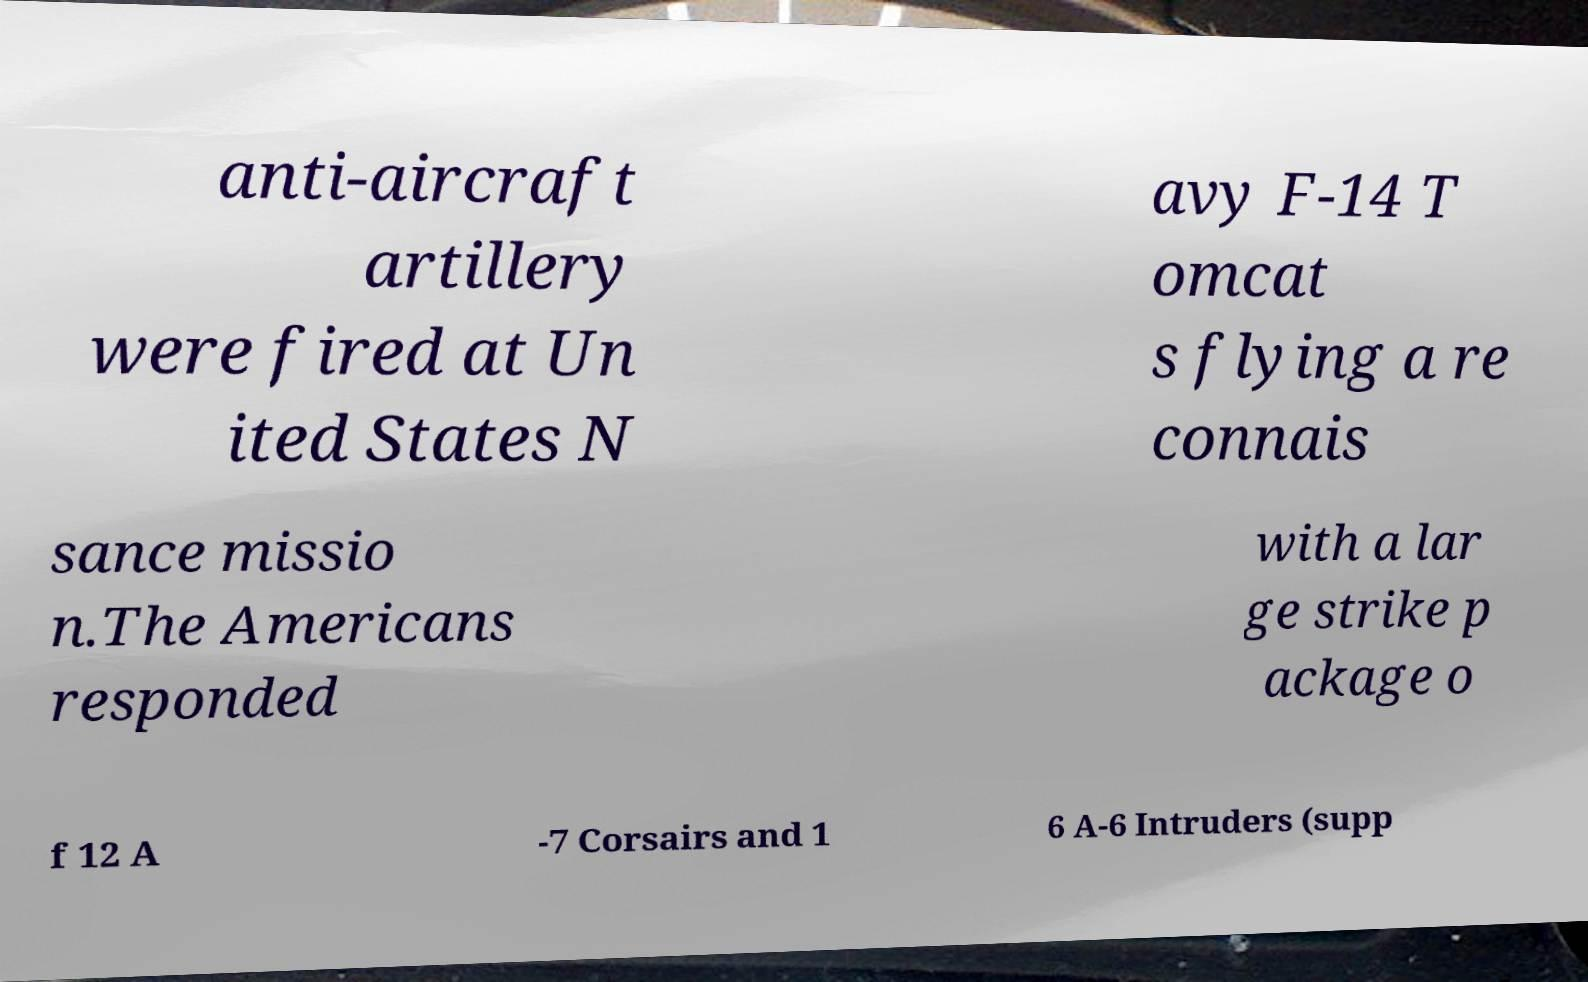I need the written content from this picture converted into text. Can you do that? anti-aircraft artillery were fired at Un ited States N avy F-14 T omcat s flying a re connais sance missio n.The Americans responded with a lar ge strike p ackage o f 12 A -7 Corsairs and 1 6 A-6 Intruders (supp 